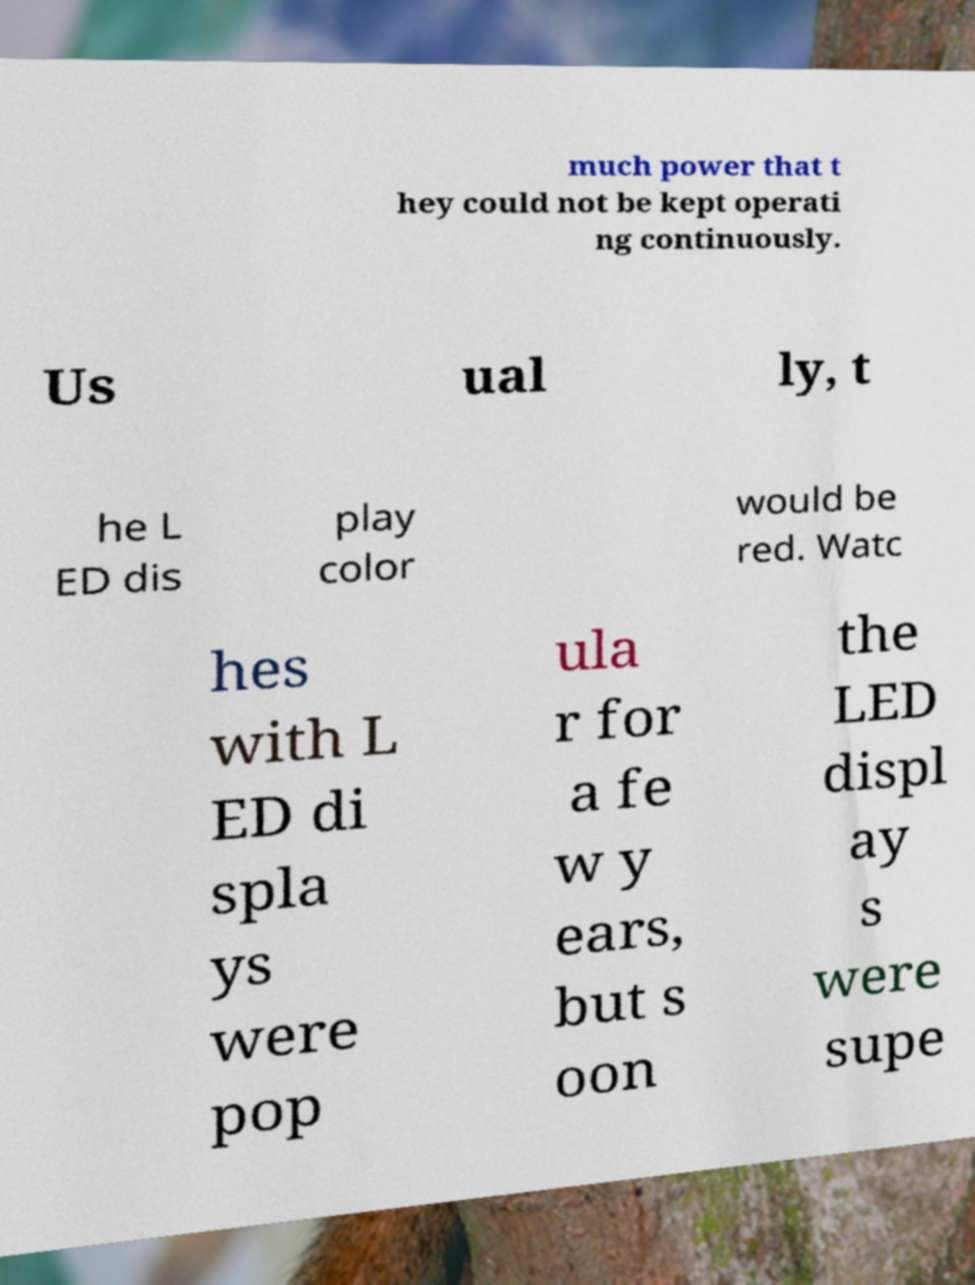Can you read and provide the text displayed in the image?This photo seems to have some interesting text. Can you extract and type it out for me? much power that t hey could not be kept operati ng continuously. Us ual ly, t he L ED dis play color would be red. Watc hes with L ED di spla ys were pop ula r for a fe w y ears, but s oon the LED displ ay s were supe 